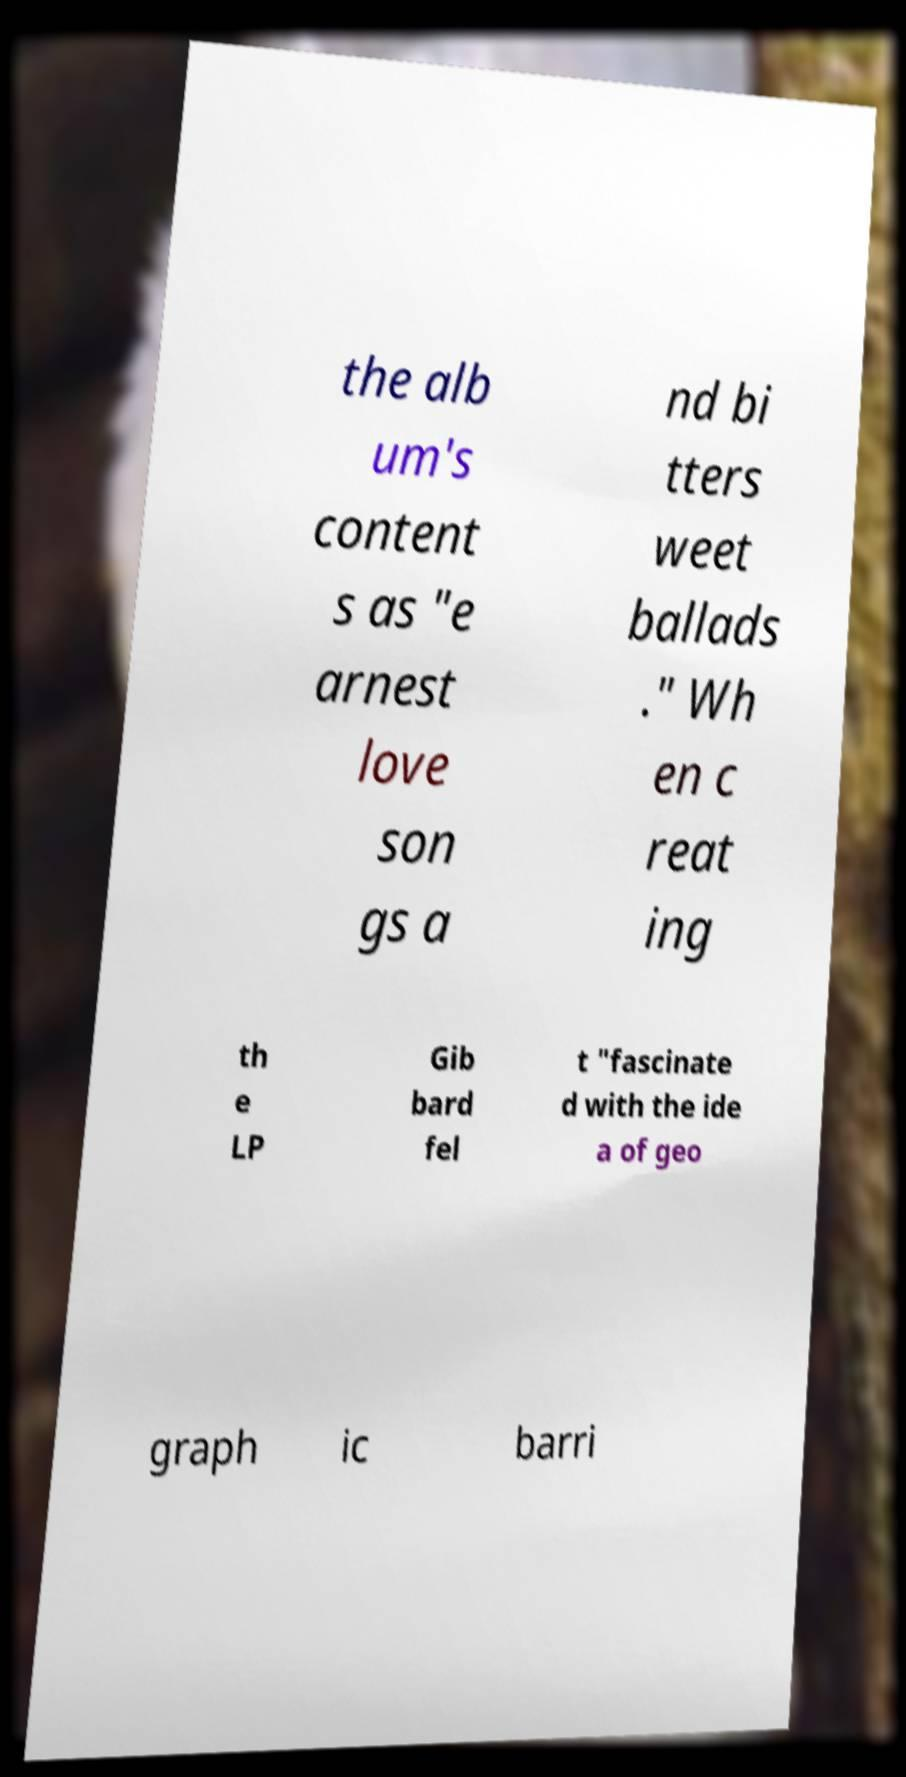Could you assist in decoding the text presented in this image and type it out clearly? the alb um's content s as "e arnest love son gs a nd bi tters weet ballads ." Wh en c reat ing th e LP Gib bard fel t "fascinate d with the ide a of geo graph ic barri 